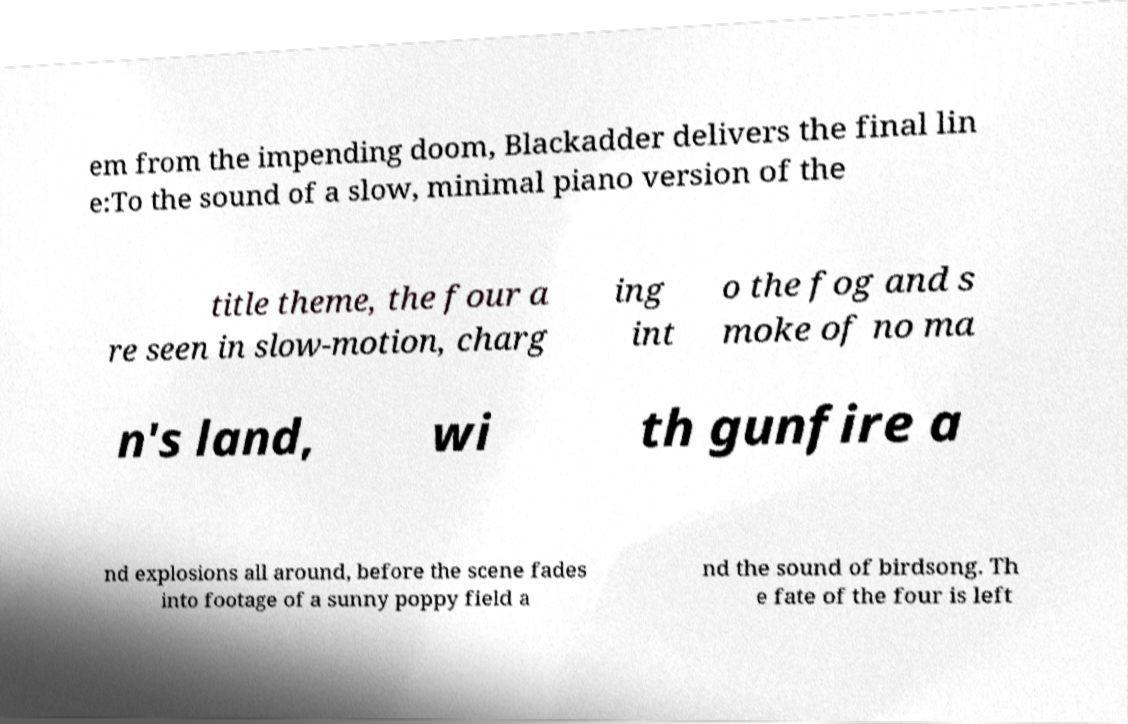What messages or text are displayed in this image? I need them in a readable, typed format. em from the impending doom, Blackadder delivers the final lin e:To the sound of a slow, minimal piano version of the title theme, the four a re seen in slow-motion, charg ing int o the fog and s moke of no ma n's land, wi th gunfire a nd explosions all around, before the scene fades into footage of a sunny poppy field a nd the sound of birdsong. Th e fate of the four is left 